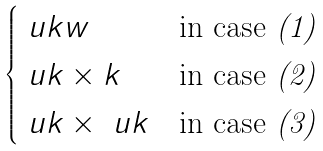Convert formula to latex. <formula><loc_0><loc_0><loc_500><loc_500>\begin{cases} \ u k w & \text {in case {\em (1)}} \\ \ u k \times k & \text {in case {\em (2)}} \\ \ u k \times \ u k & \text {in case {\em (3)}} \end{cases}</formula> 